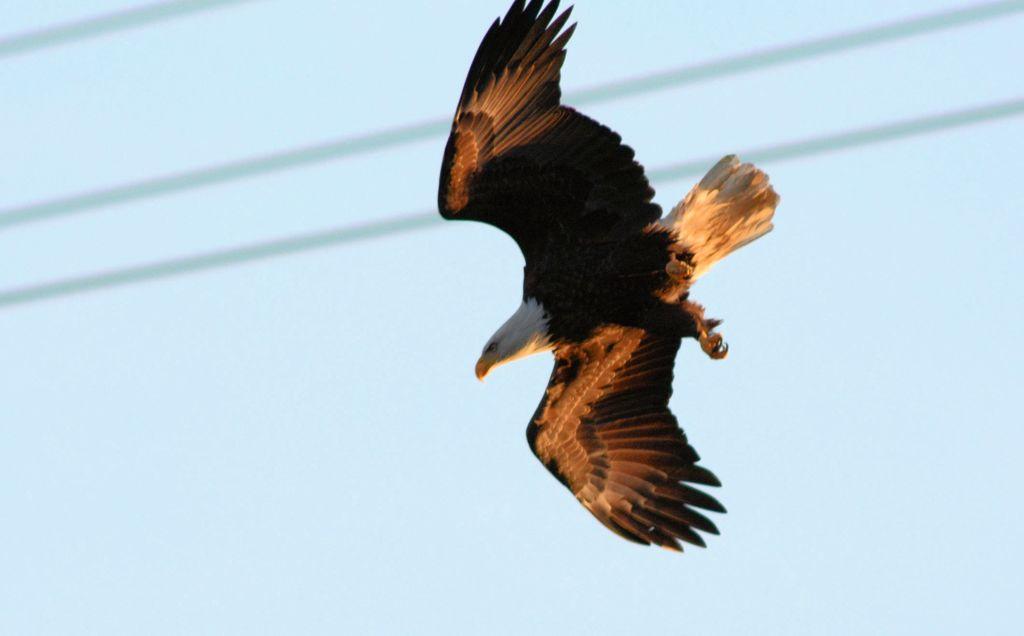Can you describe this image briefly? In the image there is a bird flying in the sky. 